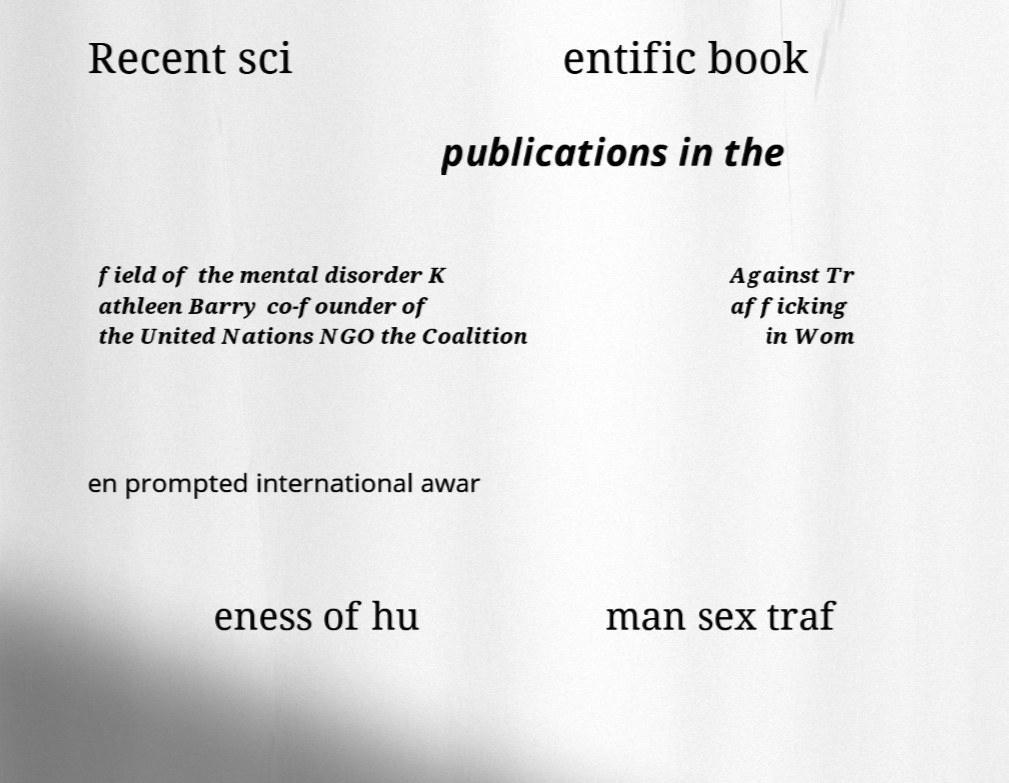Can you accurately transcribe the text from the provided image for me? Recent sci entific book publications in the field of the mental disorder K athleen Barry co-founder of the United Nations NGO the Coalition Against Tr afficking in Wom en prompted international awar eness of hu man sex traf 